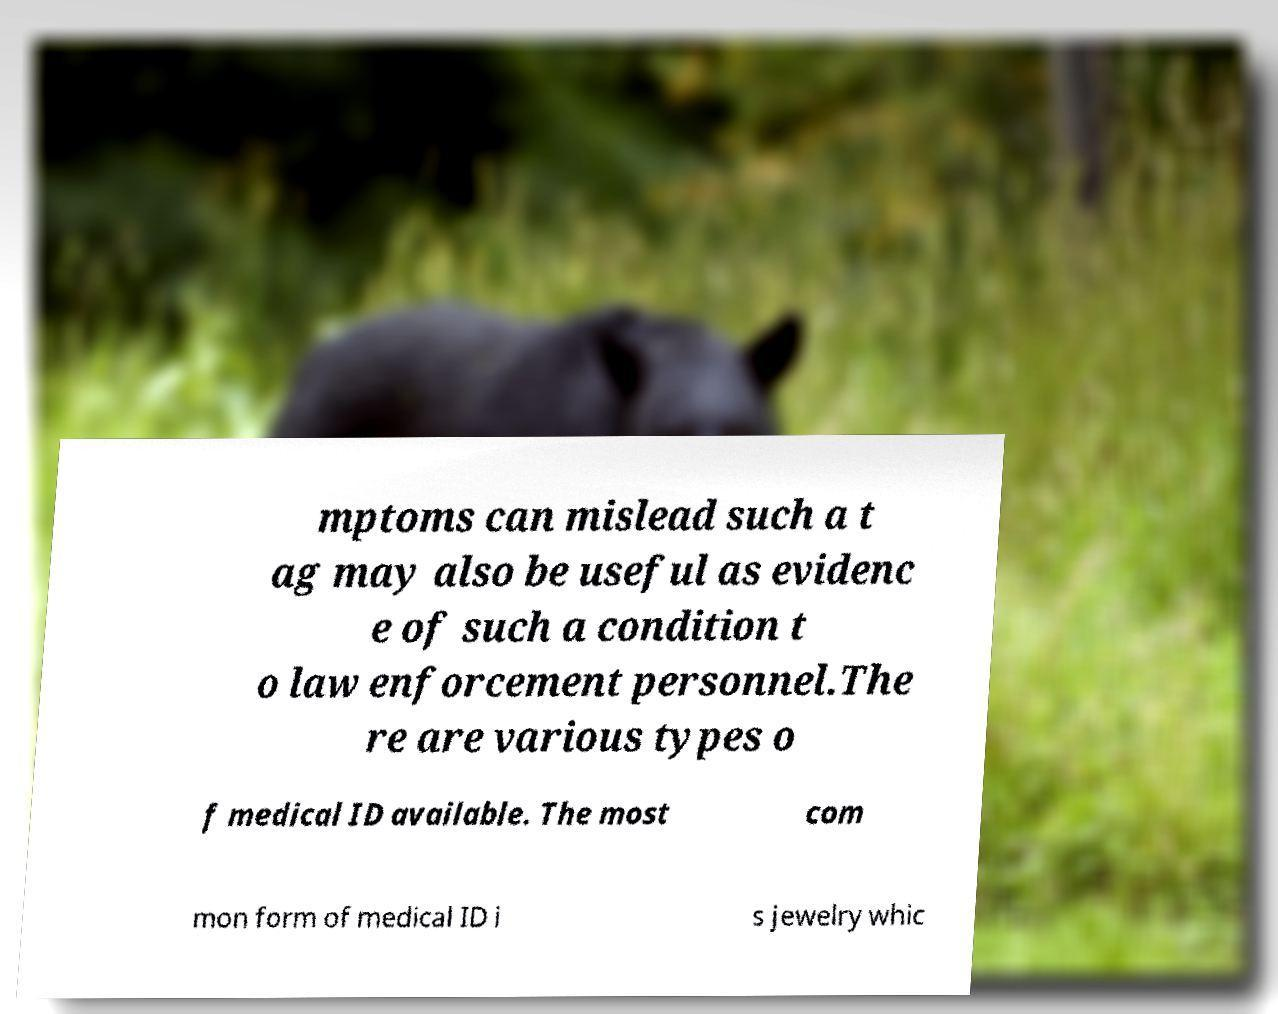There's text embedded in this image that I need extracted. Can you transcribe it verbatim? mptoms can mislead such a t ag may also be useful as evidenc e of such a condition t o law enforcement personnel.The re are various types o f medical ID available. The most com mon form of medical ID i s jewelry whic 